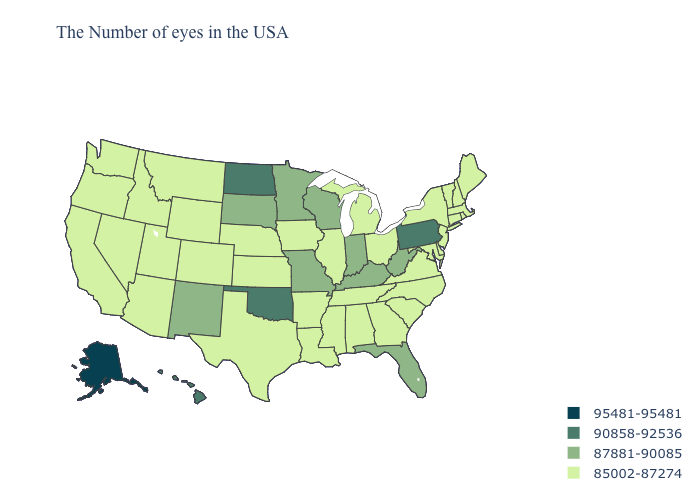Does Florida have the highest value in the South?
Short answer required. No. What is the highest value in the USA?
Write a very short answer. 95481-95481. Does Oklahoma have the lowest value in the South?
Be succinct. No. Is the legend a continuous bar?
Quick response, please. No. What is the value of New Jersey?
Answer briefly. 85002-87274. What is the highest value in states that border Texas?
Answer briefly. 90858-92536. What is the lowest value in the USA?
Short answer required. 85002-87274. Name the states that have a value in the range 85002-87274?
Keep it brief. Maine, Massachusetts, Rhode Island, New Hampshire, Vermont, Connecticut, New York, New Jersey, Delaware, Maryland, Virginia, North Carolina, South Carolina, Ohio, Georgia, Michigan, Alabama, Tennessee, Illinois, Mississippi, Louisiana, Arkansas, Iowa, Kansas, Nebraska, Texas, Wyoming, Colorado, Utah, Montana, Arizona, Idaho, Nevada, California, Washington, Oregon. Does Pennsylvania have the lowest value in the Northeast?
Short answer required. No. Does North Dakota have the lowest value in the MidWest?
Answer briefly. No. Among the states that border Illinois , which have the highest value?
Short answer required. Kentucky, Indiana, Wisconsin, Missouri. What is the value of Hawaii?
Give a very brief answer. 90858-92536. How many symbols are there in the legend?
Concise answer only. 4. Name the states that have a value in the range 85002-87274?
Answer briefly. Maine, Massachusetts, Rhode Island, New Hampshire, Vermont, Connecticut, New York, New Jersey, Delaware, Maryland, Virginia, North Carolina, South Carolina, Ohio, Georgia, Michigan, Alabama, Tennessee, Illinois, Mississippi, Louisiana, Arkansas, Iowa, Kansas, Nebraska, Texas, Wyoming, Colorado, Utah, Montana, Arizona, Idaho, Nevada, California, Washington, Oregon. 